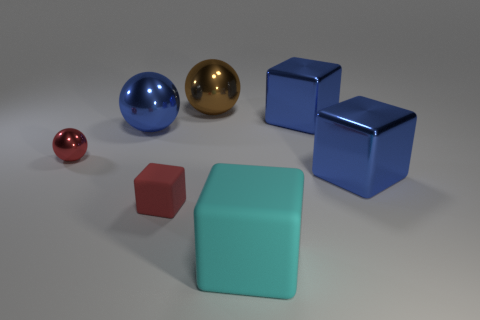There is a red sphere; is its size the same as the blue shiny thing in front of the large blue ball?
Make the answer very short. No. How many other objects are the same shape as the cyan thing?
Offer a terse response. 3. What is the shape of the tiny red object that is made of the same material as the large brown thing?
Your answer should be compact. Sphere. Are there any tiny blue metal objects?
Your answer should be very brief. No. Is the number of large blue balls right of the brown shiny ball less than the number of red objects that are behind the small red matte thing?
Your response must be concise. Yes. There is a blue metallic thing to the left of the large brown ball; what is its shape?
Your answer should be compact. Sphere. Is the material of the brown thing the same as the tiny ball?
Offer a very short reply. Yes. There is a tiny red thing that is the same shape as the large cyan rubber thing; what is it made of?
Your answer should be very brief. Rubber. Is the number of red things on the left side of the tiny ball less than the number of big metal balls?
Your answer should be very brief. Yes. There is a big cyan cube; how many cyan cubes are behind it?
Your answer should be compact. 0. 